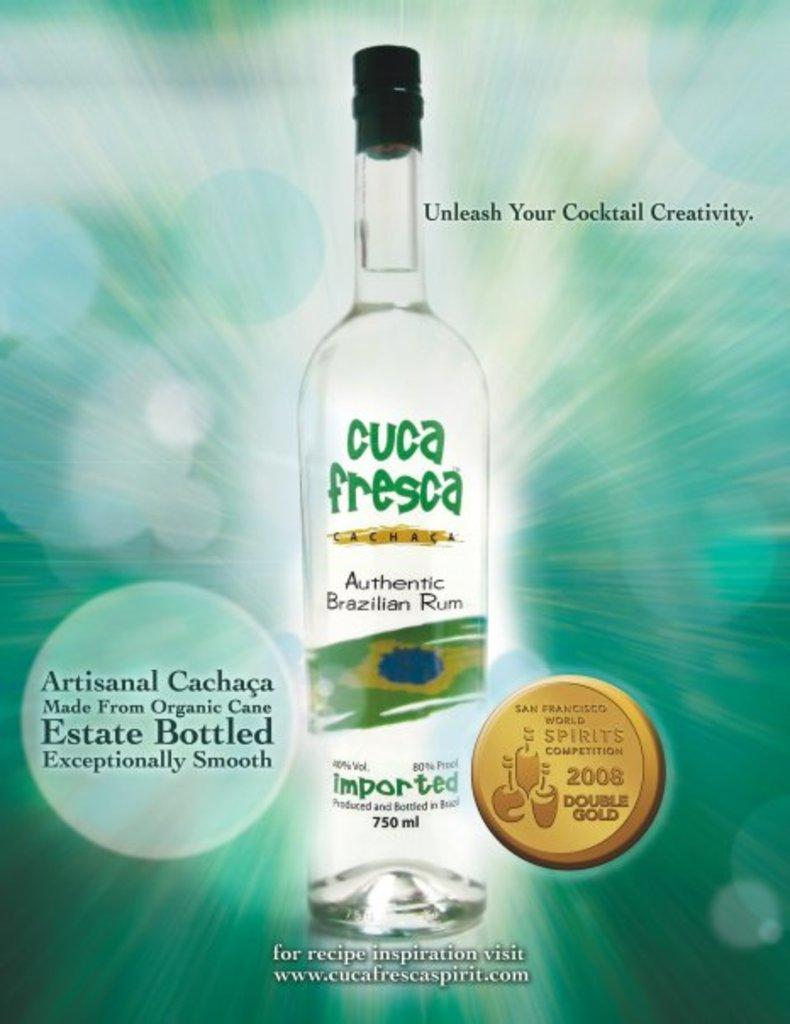<image>
Write a terse but informative summary of the picture. A bottle of cuca fresca Authentic Brazilian Rum made from organic cane and exceptionally smooth taste. 